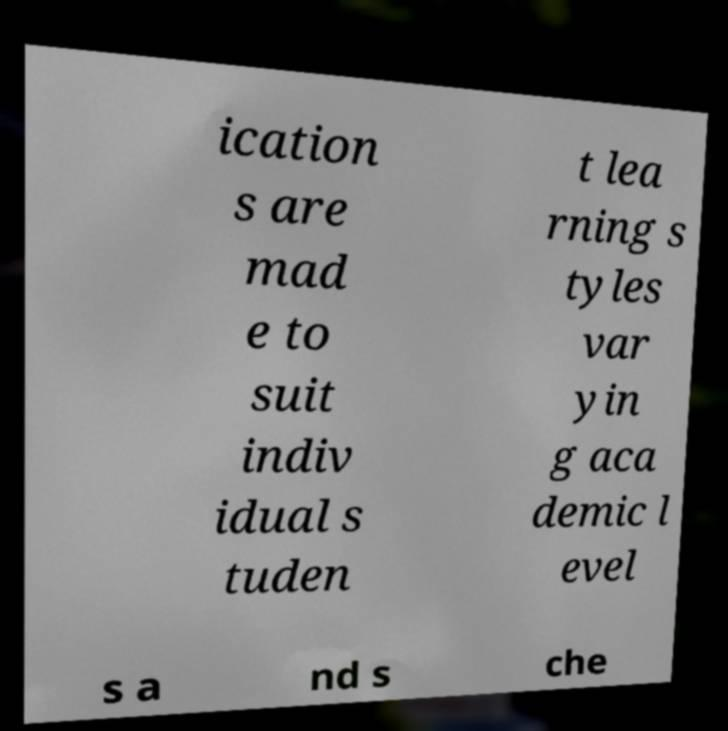Please identify and transcribe the text found in this image. ication s are mad e to suit indiv idual s tuden t lea rning s tyles var yin g aca demic l evel s a nd s che 